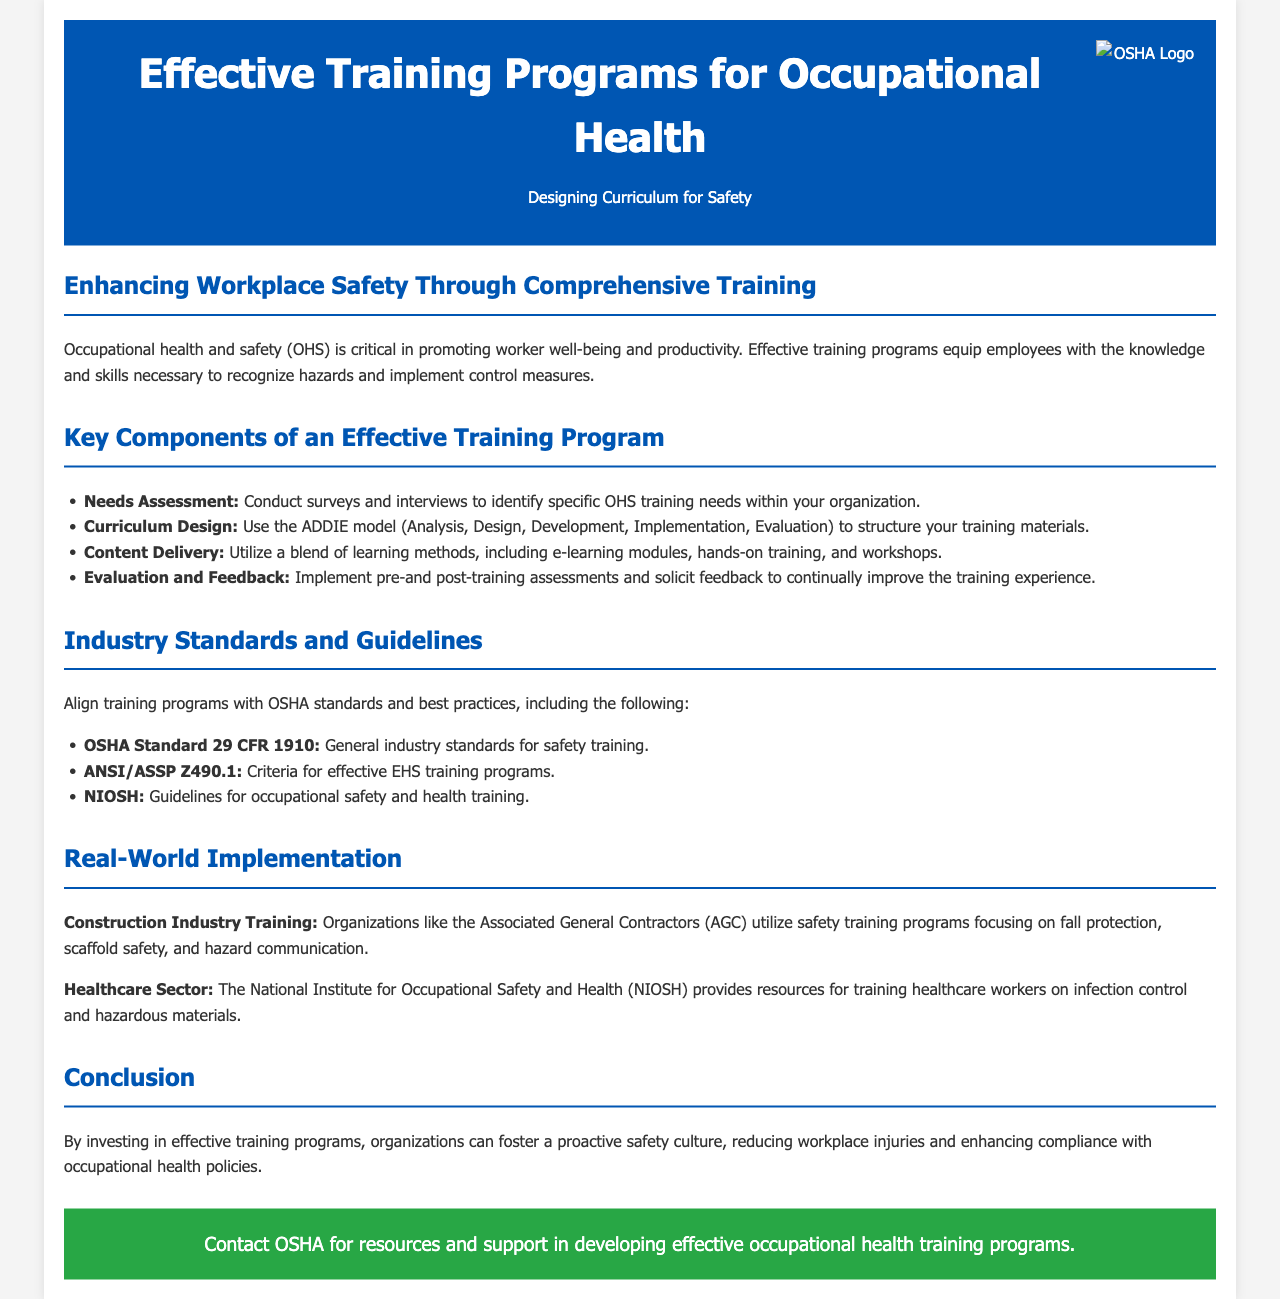What is the title of the brochure? The title of the brochure is the main heading that summarizes its content.
Answer: Effective Training Programs for Occupational Health What does OHS stand for? OHS is an abbreviation mentioned in the document, referring to occupational health and safety.
Answer: Occupational Health and Safety What model is suggested for curriculum design? The model recommended for structuring training materials is mentioned explicitly in the key components section.
Answer: ADDIE model Which OSHA standard relates to general industry safety training? The specific standard related to general industry safety training is noted in the industry standards section.
Answer: OSHA Standard 29 CFR 1910 What are the four learning methods suggested for content delivery? The document lists specific methods that should be utilized for training delivery.
Answer: E-learning modules, hands-on training, workshops What organization utilizes safety training programs in the construction industry? The document refers to an organization focused on construction industry training.
Answer: Associated General Contractors (AGC) Which section addresses the conclusion of the training program? The section that sums up the document's key message is clearly labeled.
Answer: Conclusion What guideline does NIOSH provide for training? NIOSH provides an important guideline related to a specific sector mentioned in the document.
Answer: Guidelines for occupational safety and health training 